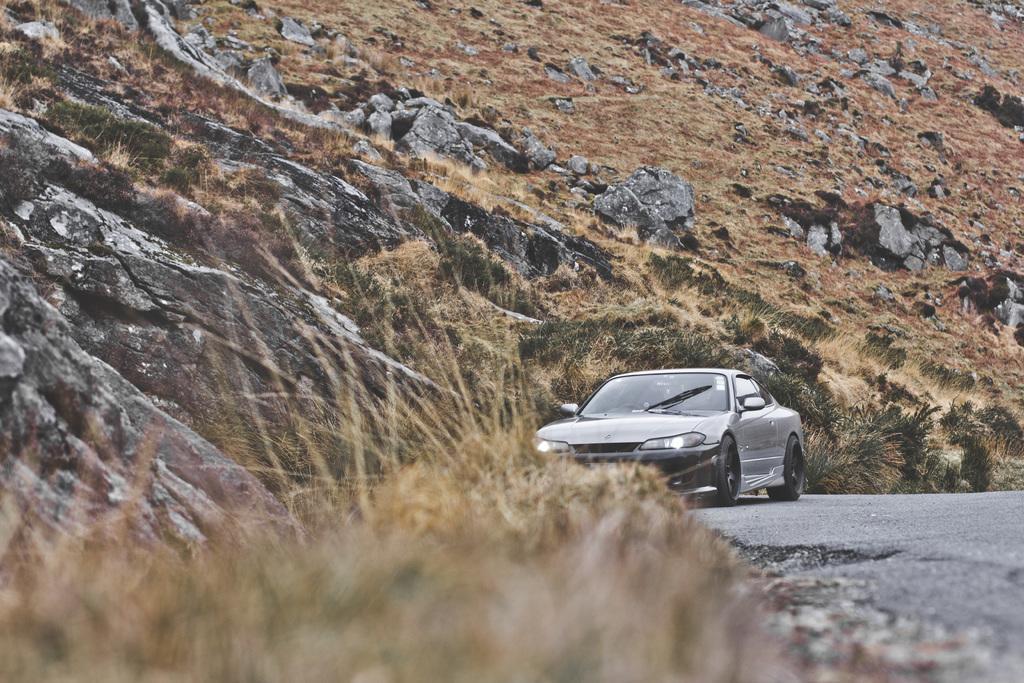Could you give a brief overview of what you see in this image? In this image we can see a car on the road. In the background of the image there is a mountain. At the bottom of the image there is dry grass. 